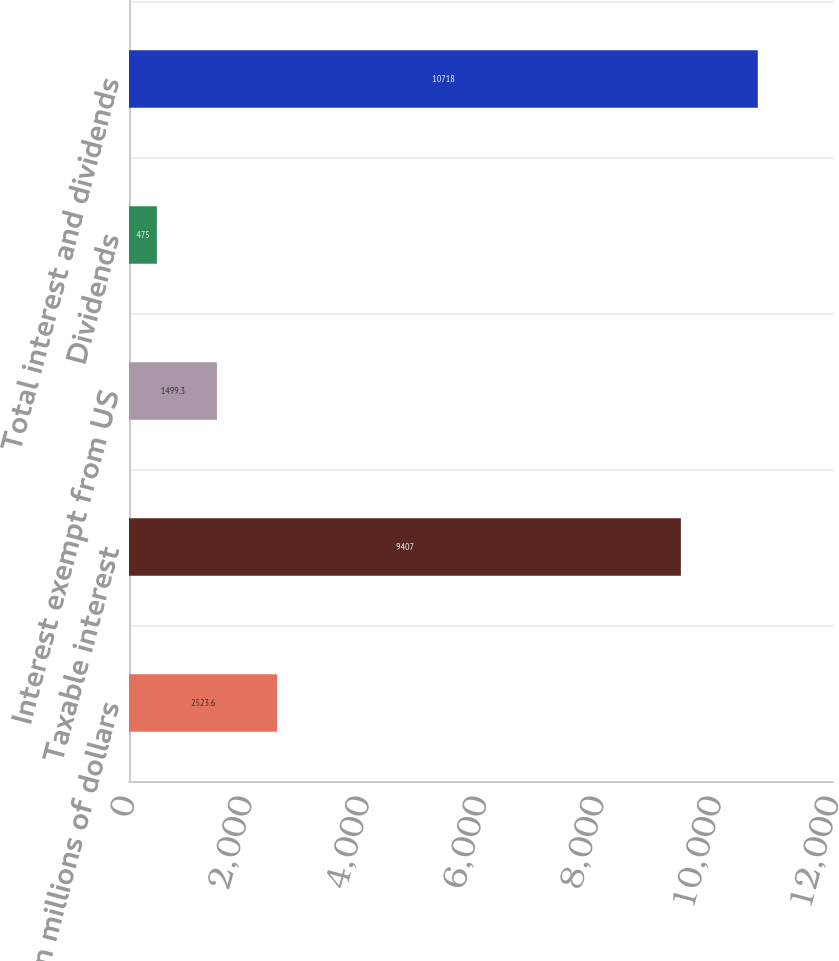Convert chart. <chart><loc_0><loc_0><loc_500><loc_500><bar_chart><fcel>In millions of dollars<fcel>Taxable interest<fcel>Interest exempt from US<fcel>Dividends<fcel>Total interest and dividends<nl><fcel>2523.6<fcel>9407<fcel>1499.3<fcel>475<fcel>10718<nl></chart> 